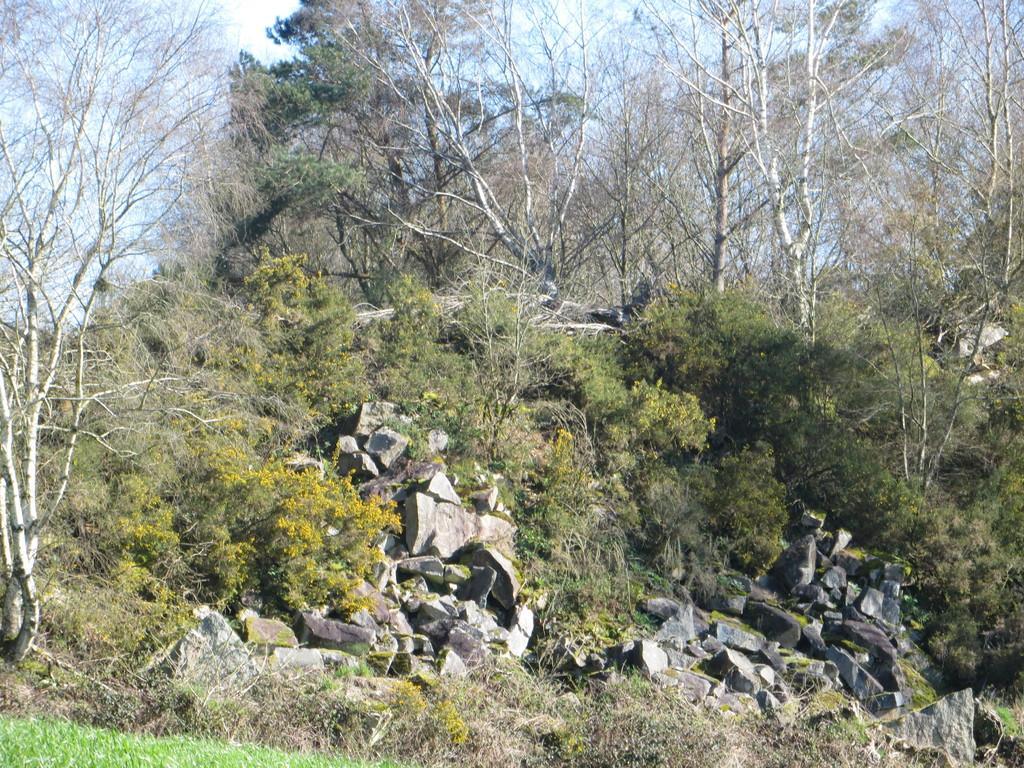Describe this image in one or two sentences. In the image there are rocks,plants and trees on a hill and above its sky. 